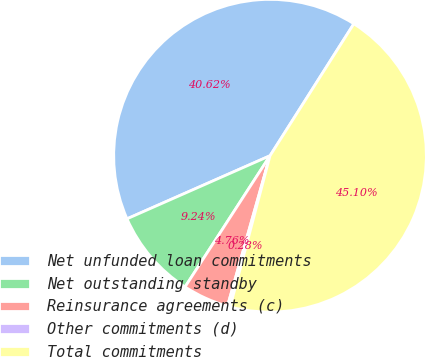<chart> <loc_0><loc_0><loc_500><loc_500><pie_chart><fcel>Net unfunded loan commitments<fcel>Net outstanding standby<fcel>Reinsurance agreements (c)<fcel>Other commitments (d)<fcel>Total commitments<nl><fcel>40.62%<fcel>9.24%<fcel>4.76%<fcel>0.28%<fcel>45.1%<nl></chart> 